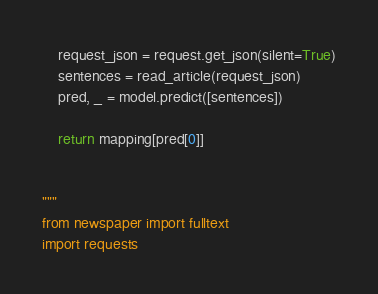Convert code to text. <code><loc_0><loc_0><loc_500><loc_500><_Python_>    request_json = request.get_json(silent=True)
    sentences = read_article(request_json)
    pred, _ = model.predict([sentences])

    return mapping[pred[0]]


"""
from newspaper import fulltext
import requests
</code> 